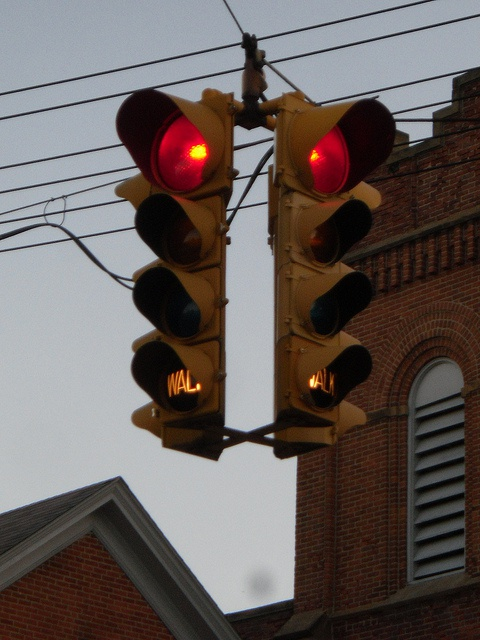Describe the objects in this image and their specific colors. I can see traffic light in darkgray, black, maroon, and brown tones and traffic light in darkgray, black, maroon, brown, and red tones in this image. 